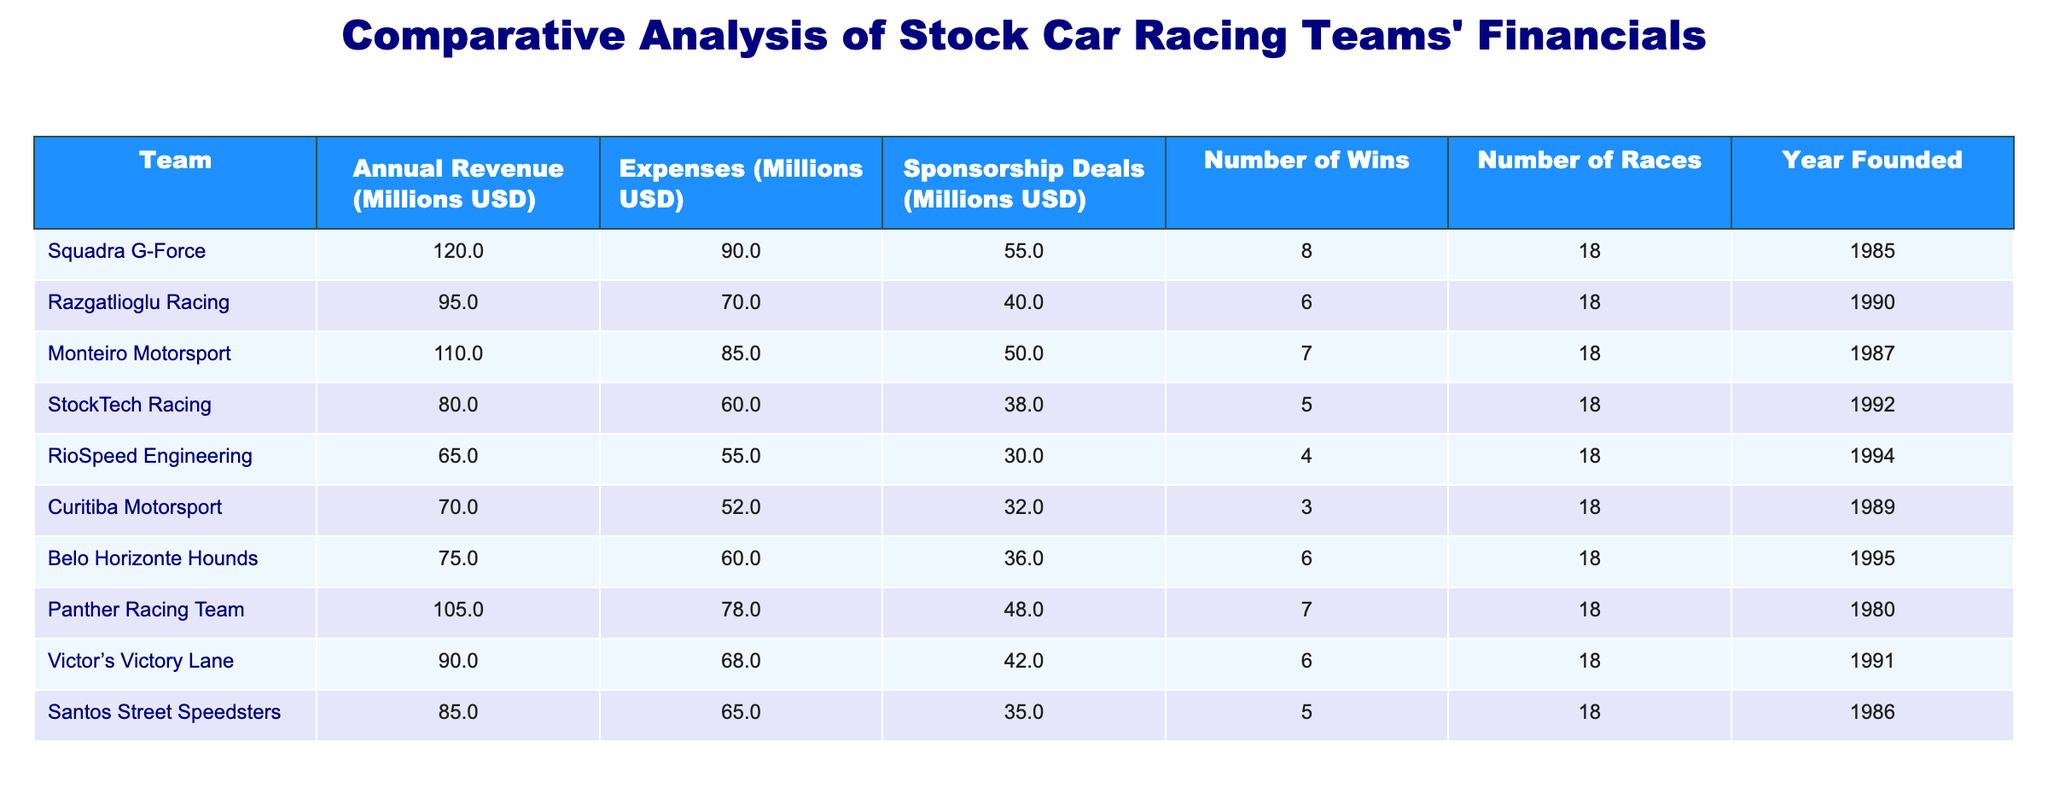What is the annual revenue of Squadra G-Force? The table lists the annual revenue for each racing team, and for Squadra G-Force, the revenue is explicitly stated as 120 million USD.
Answer: 120 million USD Which team has the highest number of sponsorship deals? By reviewing the sponsorship deals column, Squadra G-Force has 55 million USD in sponsorship deals, which is higher than all other teams listed.
Answer: Squadra G-Force What is the total annual revenue of all teams combined? The annual revenues for each team are 120, 95, 110, 80, 65, 70, 75, 105, 90, and 85 million USD. Summing these amounts gives 120 + 95 + 110 + 80 + 65 + 70 + 75 + 105 + 90 + 85 = 1,025 million USD.
Answer: 1,025 million USD Is it true that any team has more wins than Squadra G-Force? The number of wins for Squadra G-Force is 8. Looking through the wins column, no other team has more than 8 wins, confirming the statement is false.
Answer: No What is the average number of expenses for the teams listed? The expenses for the teams are 90, 70, 85, 60, 55, 52, 60, 78, 68, and 65 million USD, which sum to 70 + 85 + 60 + 55 + 52 + 60 + 78 + 68 + 65 = 60 + 70 + 90 + 85 = 80 million USD for 10 teams total. Thus, divide the total by 10: 600/10 = 70.
Answer: 70 million USD Which team has the lowest number of wins, and what is that number? Checking the number of wins for each team, RioSpeed Engineering has 4 wins, which is the lowest in the table.
Answer: RioSpeed Engineering, 4 wins What is the difference between the annual revenue of Panther Racing Team and the annual revenue of StockTech Racing? Panther Racing Team has 105 million USD in revenue, while StockTech Racing has 80 million USD. The difference is calculated as 105 - 80 = 25 million USD.
Answer: 25 million USD Has Belo Horizonte Hounds been founded before or after 1990? Belo Horizonte Hounds' founding year is 1995, which is after 1990. Thus the answer to this question is yes, it was founded after 1990.
Answer: Yes What is the median number of races held across all teams? The number of races is identical for all teams, with each competing in 18 races. Therefore, the median is simply 18, as all entries are the same.
Answer: 18 races If you rank the teams by their annual revenue, which team comes in third place? The teams ranked by annual revenue in descending order are Squadra G-Force (120 million), Monteiro Motorsport (110 million), and Panther Racing Team (105 million), making Panther Racing Team the third highest.
Answer: Panther Racing Team 